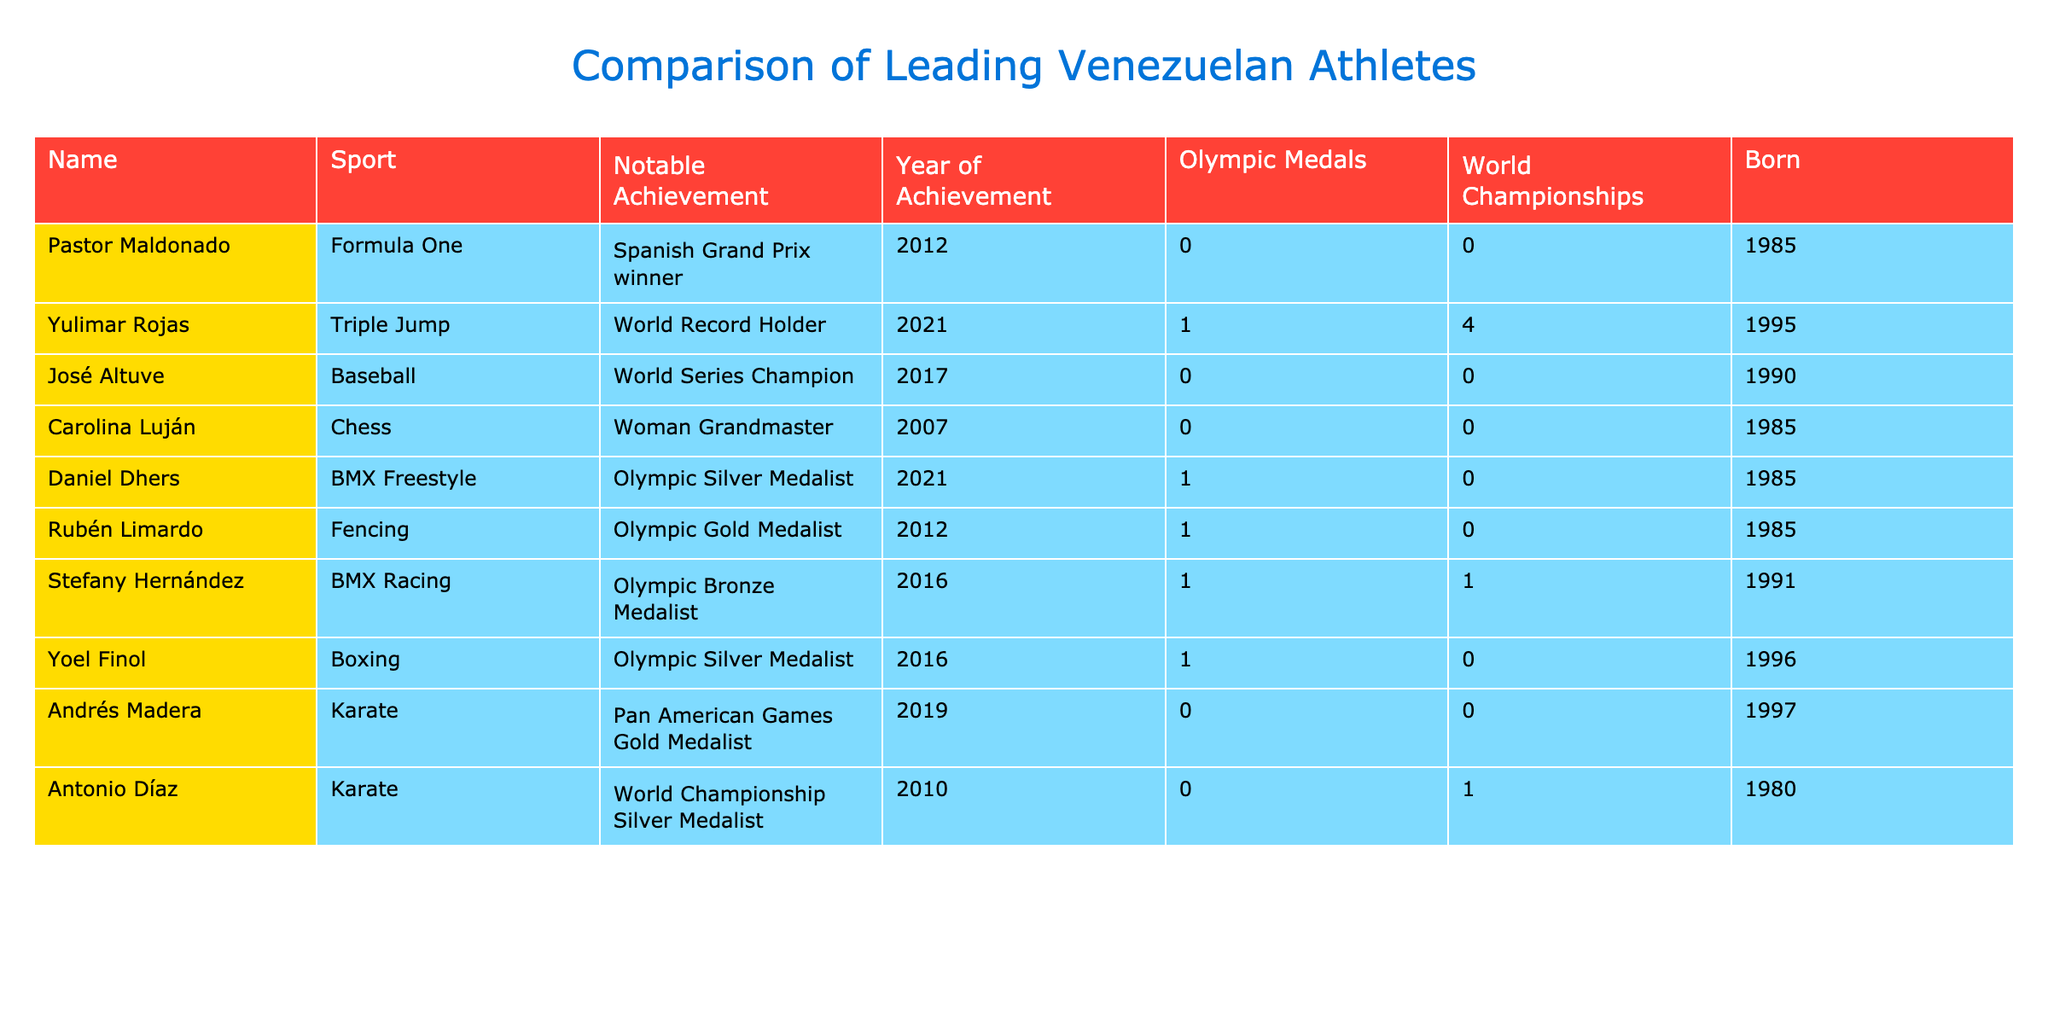What sport does Yulimar Rojas compete in? Yulimar Rojas is listed under the "Sport" column of the table, and it indicates that she competes in Triple Jump.
Answer: Triple Jump How many Olympic medals has Pastor Maldonado won? According to the table, the "Olympic Medals" column shows that Pastor Maldonado has won 0 Olympic medals.
Answer: 0 Who won an Olympic Gold Medal in Fencing? Rubén Limardo is identified in the table as the athlete who has won an Olympic Gold Medal in Fencing, as indicated in the "Notable Achievement" column.
Answer: Rubén Limardo What is the total number of Olympic medals won by Venezuelan athletes listed in the table? By adding the Olympic medals from each athlete: 1 (Yulimar Rojas) + 1 (Daniel Dhers) + 1 (Rubén Limardo) + 1 (Stefany Hernández) + 1 (Yoel Finol) = 5. Therefore, the total number of Olympic medals is 5.
Answer: 5 Is José Altuve a World Champion? The table indicates that José Altuve is a World Series Champion in baseball, but it does not specify any World Championship titles in his record. Thus, the answer is no.
Answer: No How many athletes were born in the year 1985, and what sports do they compete in? By reviewing the "Born" column, we find three athletes born in 1985: Pastor Maldonado (Formula One), Carolina Luján (Chess), and Daniel Dhers (BMX Freestyle).
Answer: 3 (Formula One, Chess, BMX Freestyle) Which sport does Stefany Hernández compete in, and what medal did she win at the Olympics? The table shows that Stefany Hernández competes in BMX Racing, and her notable achievement is winning an Olympic Bronze Medal in 2016.
Answer: BMX Racing, Bronze Medal What is the average number of World Championships among the athletes? Adding the World Championships: 0 + 4 + 0 + 0 + 0 + 1 + 0 + 0 + 1 = 6. There are 10 athletes in total, so the average is 6/10 = 0.6.
Answer: 0.6 Did any of the athletes in the table win medals at the World Championships? Yes, the table contains athletes who won medals. Yulimar Rojas has 4 World Championships, and Antonio Díaz has 1. This shows that at least some athletes have won medals at World Championships.
Answer: Yes 